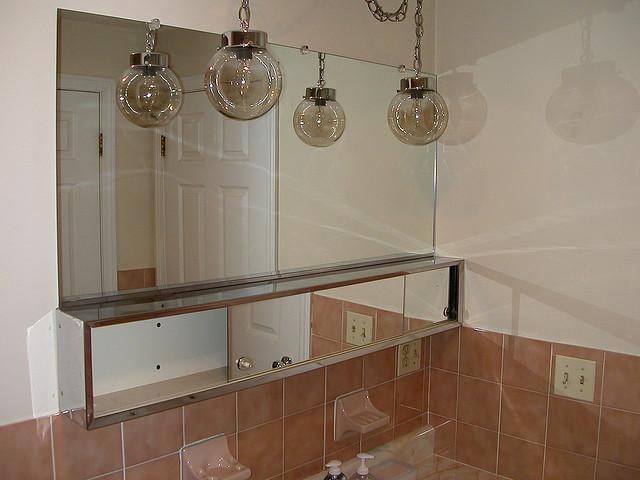How many people wear hat?
Give a very brief answer. 0. 